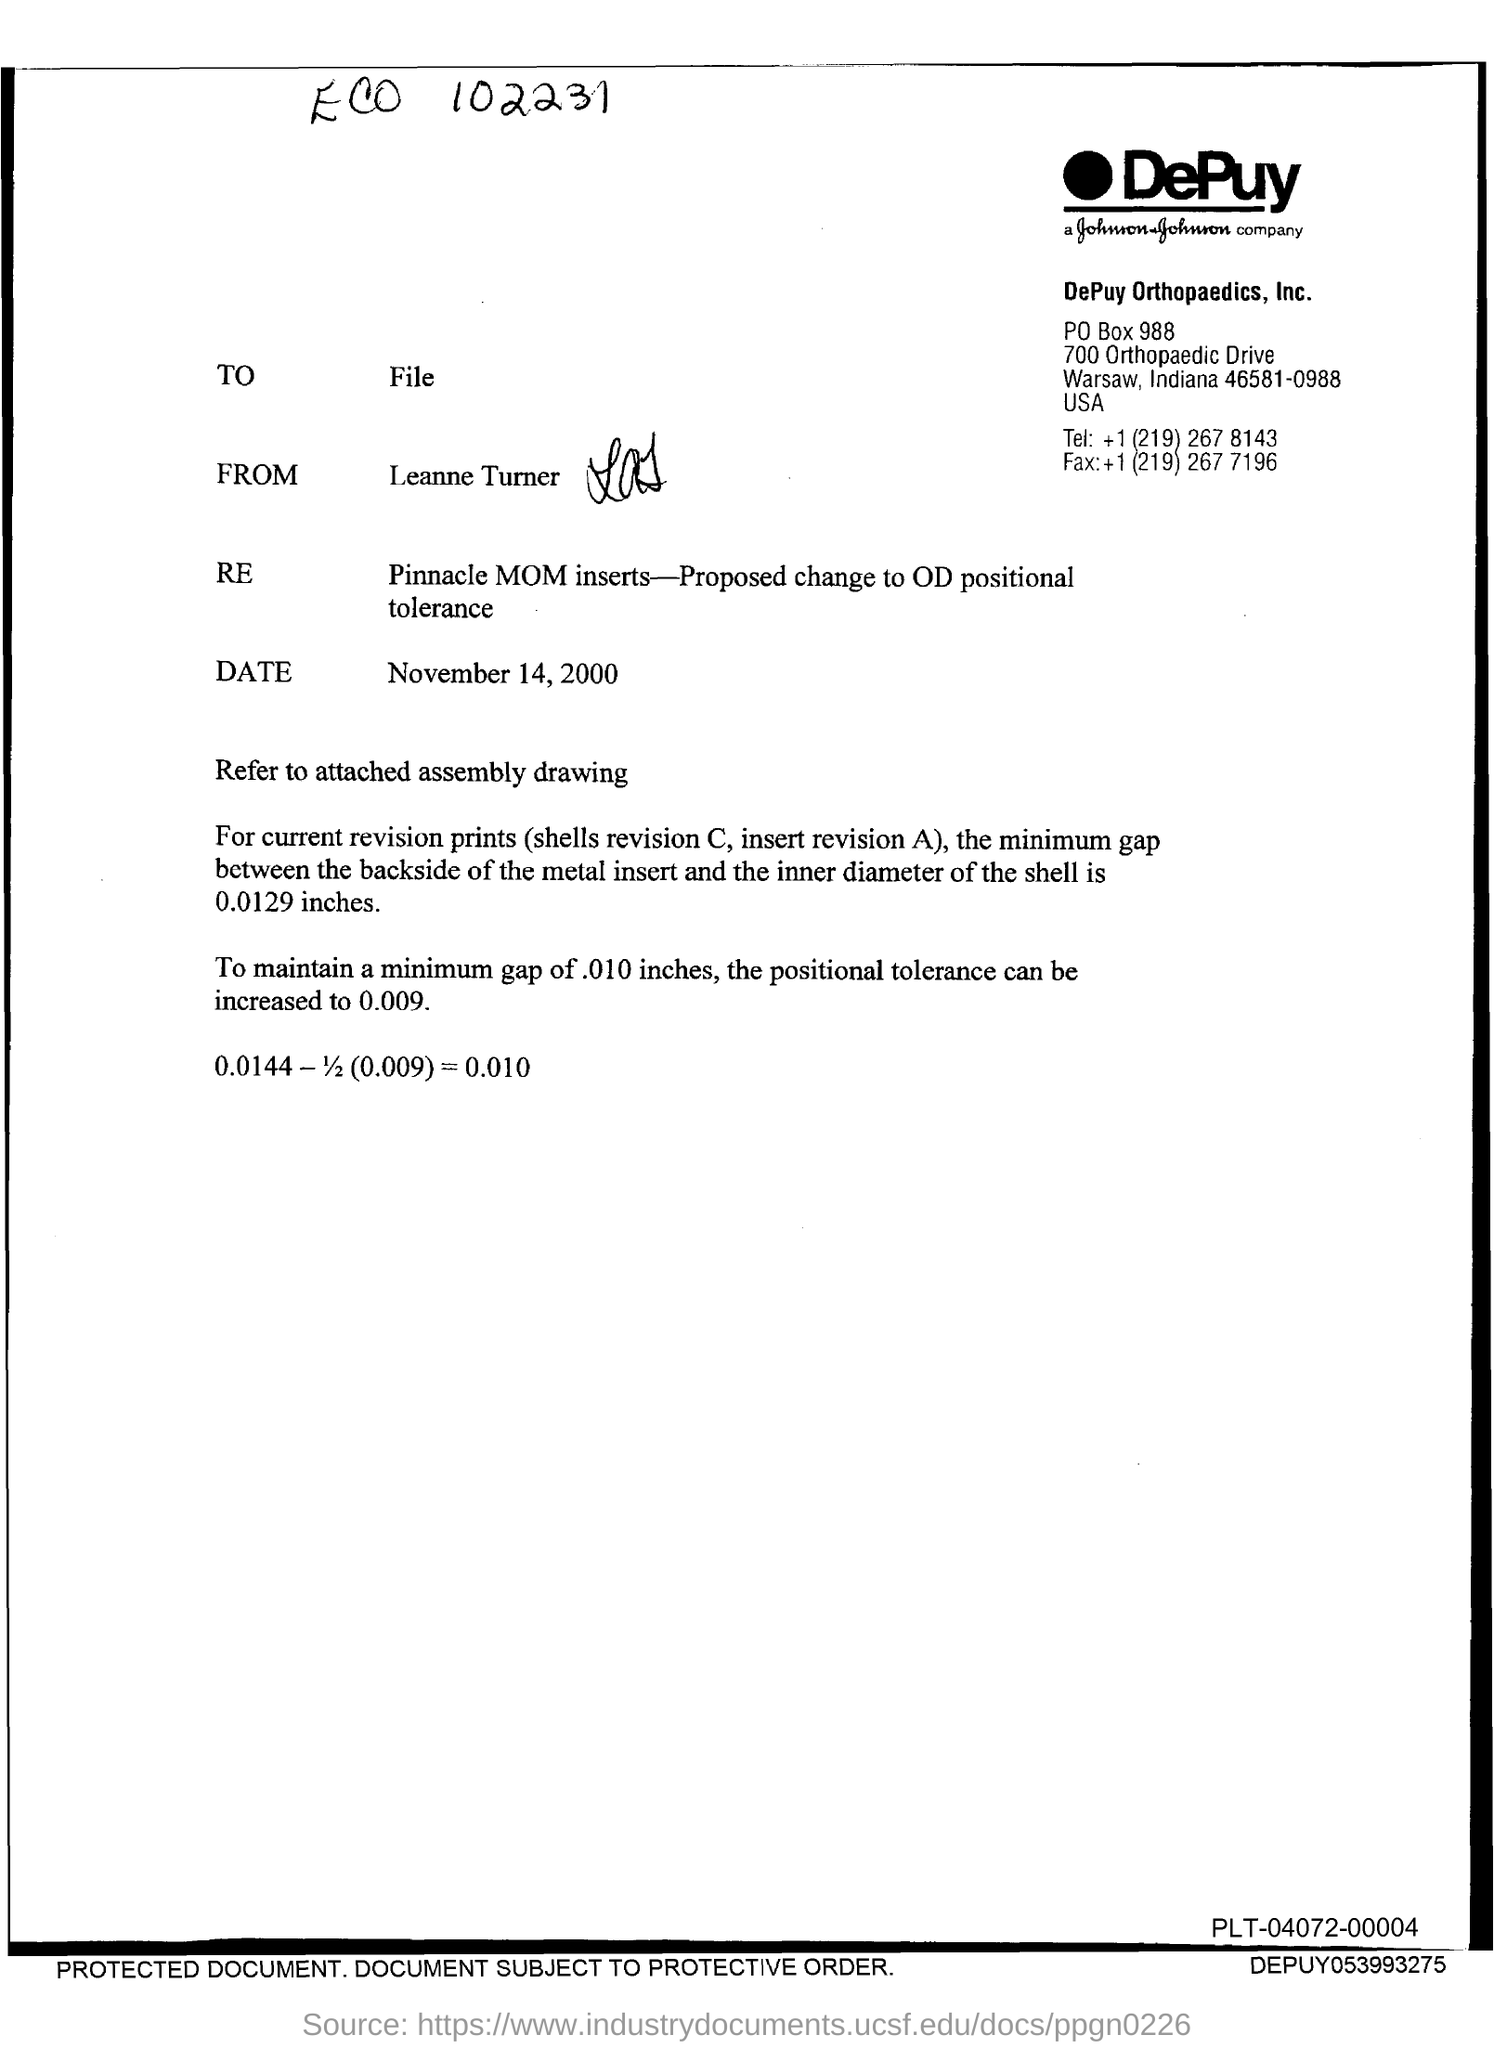Who is the sender of this letter?
Your response must be concise. LEANNE TURNER. What is the date mentioned in this letter?
Your response must be concise. NOVEMBER 14, 2000. What is the fax no given?
Ensure brevity in your answer.  +1 (219) 267 7196. 